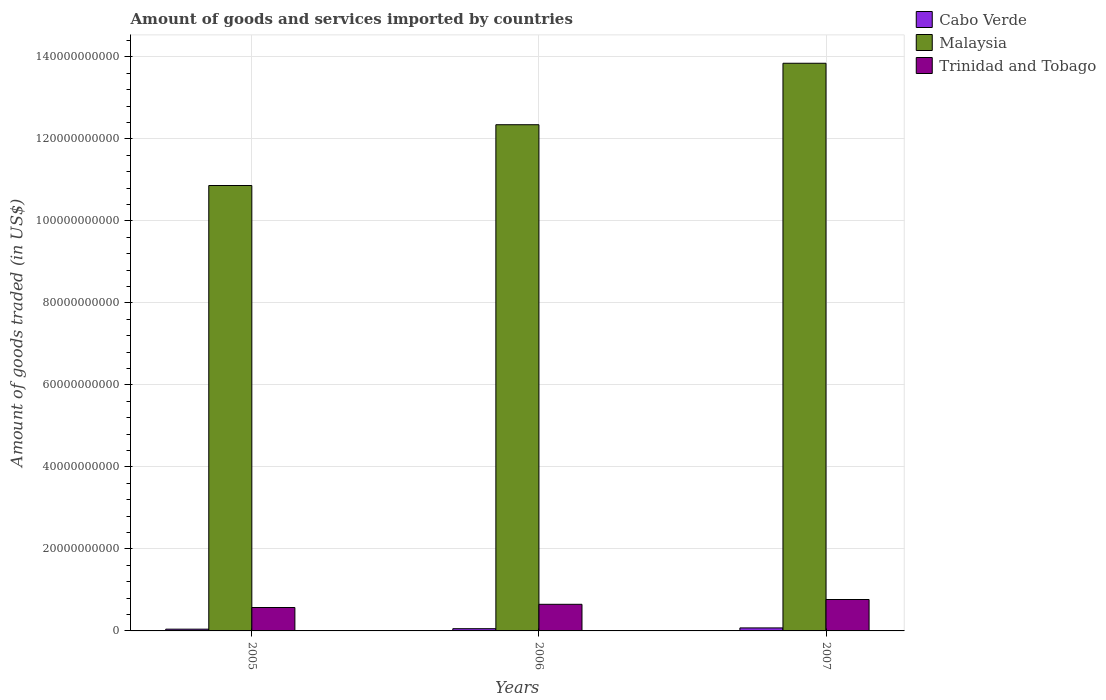How many different coloured bars are there?
Provide a short and direct response. 3. How many groups of bars are there?
Provide a short and direct response. 3. How many bars are there on the 3rd tick from the right?
Offer a very short reply. 3. In how many cases, is the number of bars for a given year not equal to the number of legend labels?
Provide a succinct answer. 0. What is the total amount of goods and services imported in Malaysia in 2005?
Your answer should be very brief. 1.09e+11. Across all years, what is the maximum total amount of goods and services imported in Trinidad and Tobago?
Give a very brief answer. 7.66e+09. Across all years, what is the minimum total amount of goods and services imported in Malaysia?
Your answer should be very brief. 1.09e+11. In which year was the total amount of goods and services imported in Trinidad and Tobago maximum?
Your answer should be compact. 2007. In which year was the total amount of goods and services imported in Cabo Verde minimum?
Your answer should be compact. 2005. What is the total total amount of goods and services imported in Malaysia in the graph?
Offer a terse response. 3.70e+11. What is the difference between the total amount of goods and services imported in Trinidad and Tobago in 2005 and that in 2007?
Provide a short and direct response. -1.95e+09. What is the difference between the total amount of goods and services imported in Malaysia in 2007 and the total amount of goods and services imported in Trinidad and Tobago in 2005?
Give a very brief answer. 1.33e+11. What is the average total amount of goods and services imported in Trinidad and Tobago per year?
Make the answer very short. 6.62e+09. In the year 2005, what is the difference between the total amount of goods and services imported in Trinidad and Tobago and total amount of goods and services imported in Cabo Verde?
Offer a very short reply. 5.28e+09. What is the ratio of the total amount of goods and services imported in Trinidad and Tobago in 2005 to that in 2006?
Provide a succinct answer. 0.88. What is the difference between the highest and the second highest total amount of goods and services imported in Cabo Verde?
Keep it short and to the point. 1.87e+08. What is the difference between the highest and the lowest total amount of goods and services imported in Malaysia?
Your response must be concise. 2.98e+1. What does the 2nd bar from the left in 2006 represents?
Offer a terse response. Malaysia. What does the 3rd bar from the right in 2006 represents?
Your answer should be very brief. Cabo Verde. Are all the bars in the graph horizontal?
Offer a very short reply. No. How many years are there in the graph?
Keep it short and to the point. 3. What is the difference between two consecutive major ticks on the Y-axis?
Your response must be concise. 2.00e+1. Does the graph contain any zero values?
Provide a succinct answer. No. What is the title of the graph?
Keep it short and to the point. Amount of goods and services imported by countries. Does "Middle East & North Africa (developing only)" appear as one of the legend labels in the graph?
Your answer should be compact. No. What is the label or title of the X-axis?
Your answer should be very brief. Years. What is the label or title of the Y-axis?
Make the answer very short. Amount of goods traded (in US$). What is the Amount of goods traded (in US$) in Cabo Verde in 2005?
Provide a succinct answer. 4.27e+08. What is the Amount of goods traded (in US$) in Malaysia in 2005?
Your response must be concise. 1.09e+11. What is the Amount of goods traded (in US$) in Trinidad and Tobago in 2005?
Offer a very short reply. 5.71e+09. What is the Amount of goods traded (in US$) in Cabo Verde in 2006?
Your answer should be compact. 5.45e+08. What is the Amount of goods traded (in US$) in Malaysia in 2006?
Offer a terse response. 1.23e+11. What is the Amount of goods traded (in US$) of Trinidad and Tobago in 2006?
Make the answer very short. 6.49e+09. What is the Amount of goods traded (in US$) in Cabo Verde in 2007?
Make the answer very short. 7.32e+08. What is the Amount of goods traded (in US$) in Malaysia in 2007?
Your response must be concise. 1.38e+11. What is the Amount of goods traded (in US$) of Trinidad and Tobago in 2007?
Give a very brief answer. 7.66e+09. Across all years, what is the maximum Amount of goods traded (in US$) in Cabo Verde?
Offer a terse response. 7.32e+08. Across all years, what is the maximum Amount of goods traded (in US$) in Malaysia?
Make the answer very short. 1.38e+11. Across all years, what is the maximum Amount of goods traded (in US$) in Trinidad and Tobago?
Provide a short and direct response. 7.66e+09. Across all years, what is the minimum Amount of goods traded (in US$) of Cabo Verde?
Provide a short and direct response. 4.27e+08. Across all years, what is the minimum Amount of goods traded (in US$) in Malaysia?
Ensure brevity in your answer.  1.09e+11. Across all years, what is the minimum Amount of goods traded (in US$) of Trinidad and Tobago?
Provide a short and direct response. 5.71e+09. What is the total Amount of goods traded (in US$) in Cabo Verde in the graph?
Offer a terse response. 1.70e+09. What is the total Amount of goods traded (in US$) of Malaysia in the graph?
Offer a terse response. 3.70e+11. What is the total Amount of goods traded (in US$) in Trinidad and Tobago in the graph?
Offer a very short reply. 1.99e+1. What is the difference between the Amount of goods traded (in US$) of Cabo Verde in 2005 and that in 2006?
Your response must be concise. -1.18e+08. What is the difference between the Amount of goods traded (in US$) of Malaysia in 2005 and that in 2006?
Give a very brief answer. -1.48e+1. What is the difference between the Amount of goods traded (in US$) in Trinidad and Tobago in 2005 and that in 2006?
Your answer should be compact. -7.81e+08. What is the difference between the Amount of goods traded (in US$) in Cabo Verde in 2005 and that in 2007?
Provide a succinct answer. -3.05e+08. What is the difference between the Amount of goods traded (in US$) in Malaysia in 2005 and that in 2007?
Give a very brief answer. -2.98e+1. What is the difference between the Amount of goods traded (in US$) in Trinidad and Tobago in 2005 and that in 2007?
Provide a short and direct response. -1.95e+09. What is the difference between the Amount of goods traded (in US$) in Cabo Verde in 2006 and that in 2007?
Give a very brief answer. -1.87e+08. What is the difference between the Amount of goods traded (in US$) of Malaysia in 2006 and that in 2007?
Make the answer very short. -1.50e+1. What is the difference between the Amount of goods traded (in US$) in Trinidad and Tobago in 2006 and that in 2007?
Offer a terse response. -1.17e+09. What is the difference between the Amount of goods traded (in US$) in Cabo Verde in 2005 and the Amount of goods traded (in US$) in Malaysia in 2006?
Provide a short and direct response. -1.23e+11. What is the difference between the Amount of goods traded (in US$) in Cabo Verde in 2005 and the Amount of goods traded (in US$) in Trinidad and Tobago in 2006?
Keep it short and to the point. -6.06e+09. What is the difference between the Amount of goods traded (in US$) of Malaysia in 2005 and the Amount of goods traded (in US$) of Trinidad and Tobago in 2006?
Give a very brief answer. 1.02e+11. What is the difference between the Amount of goods traded (in US$) of Cabo Verde in 2005 and the Amount of goods traded (in US$) of Malaysia in 2007?
Your answer should be compact. -1.38e+11. What is the difference between the Amount of goods traded (in US$) in Cabo Verde in 2005 and the Amount of goods traded (in US$) in Trinidad and Tobago in 2007?
Ensure brevity in your answer.  -7.24e+09. What is the difference between the Amount of goods traded (in US$) of Malaysia in 2005 and the Amount of goods traded (in US$) of Trinidad and Tobago in 2007?
Provide a succinct answer. 1.01e+11. What is the difference between the Amount of goods traded (in US$) in Cabo Verde in 2006 and the Amount of goods traded (in US$) in Malaysia in 2007?
Make the answer very short. -1.38e+11. What is the difference between the Amount of goods traded (in US$) of Cabo Verde in 2006 and the Amount of goods traded (in US$) of Trinidad and Tobago in 2007?
Make the answer very short. -7.12e+09. What is the difference between the Amount of goods traded (in US$) of Malaysia in 2006 and the Amount of goods traded (in US$) of Trinidad and Tobago in 2007?
Your answer should be compact. 1.16e+11. What is the average Amount of goods traded (in US$) in Cabo Verde per year?
Provide a succinct answer. 5.68e+08. What is the average Amount of goods traded (in US$) of Malaysia per year?
Your answer should be compact. 1.23e+11. What is the average Amount of goods traded (in US$) in Trinidad and Tobago per year?
Provide a short and direct response. 6.62e+09. In the year 2005, what is the difference between the Amount of goods traded (in US$) of Cabo Verde and Amount of goods traded (in US$) of Malaysia?
Your answer should be compact. -1.08e+11. In the year 2005, what is the difference between the Amount of goods traded (in US$) in Cabo Verde and Amount of goods traded (in US$) in Trinidad and Tobago?
Offer a terse response. -5.28e+09. In the year 2005, what is the difference between the Amount of goods traded (in US$) of Malaysia and Amount of goods traded (in US$) of Trinidad and Tobago?
Offer a terse response. 1.03e+11. In the year 2006, what is the difference between the Amount of goods traded (in US$) of Cabo Verde and Amount of goods traded (in US$) of Malaysia?
Give a very brief answer. -1.23e+11. In the year 2006, what is the difference between the Amount of goods traded (in US$) of Cabo Verde and Amount of goods traded (in US$) of Trinidad and Tobago?
Offer a terse response. -5.95e+09. In the year 2006, what is the difference between the Amount of goods traded (in US$) in Malaysia and Amount of goods traded (in US$) in Trinidad and Tobago?
Give a very brief answer. 1.17e+11. In the year 2007, what is the difference between the Amount of goods traded (in US$) of Cabo Verde and Amount of goods traded (in US$) of Malaysia?
Provide a short and direct response. -1.38e+11. In the year 2007, what is the difference between the Amount of goods traded (in US$) of Cabo Verde and Amount of goods traded (in US$) of Trinidad and Tobago?
Keep it short and to the point. -6.93e+09. In the year 2007, what is the difference between the Amount of goods traded (in US$) in Malaysia and Amount of goods traded (in US$) in Trinidad and Tobago?
Provide a short and direct response. 1.31e+11. What is the ratio of the Amount of goods traded (in US$) of Cabo Verde in 2005 to that in 2006?
Ensure brevity in your answer.  0.78. What is the ratio of the Amount of goods traded (in US$) of Malaysia in 2005 to that in 2006?
Give a very brief answer. 0.88. What is the ratio of the Amount of goods traded (in US$) of Trinidad and Tobago in 2005 to that in 2006?
Your answer should be very brief. 0.88. What is the ratio of the Amount of goods traded (in US$) of Cabo Verde in 2005 to that in 2007?
Offer a very short reply. 0.58. What is the ratio of the Amount of goods traded (in US$) of Malaysia in 2005 to that in 2007?
Your response must be concise. 0.78. What is the ratio of the Amount of goods traded (in US$) in Trinidad and Tobago in 2005 to that in 2007?
Make the answer very short. 0.75. What is the ratio of the Amount of goods traded (in US$) in Cabo Verde in 2006 to that in 2007?
Offer a very short reply. 0.74. What is the ratio of the Amount of goods traded (in US$) of Malaysia in 2006 to that in 2007?
Give a very brief answer. 0.89. What is the ratio of the Amount of goods traded (in US$) in Trinidad and Tobago in 2006 to that in 2007?
Keep it short and to the point. 0.85. What is the difference between the highest and the second highest Amount of goods traded (in US$) of Cabo Verde?
Ensure brevity in your answer.  1.87e+08. What is the difference between the highest and the second highest Amount of goods traded (in US$) in Malaysia?
Provide a short and direct response. 1.50e+1. What is the difference between the highest and the second highest Amount of goods traded (in US$) of Trinidad and Tobago?
Offer a very short reply. 1.17e+09. What is the difference between the highest and the lowest Amount of goods traded (in US$) in Cabo Verde?
Offer a very short reply. 3.05e+08. What is the difference between the highest and the lowest Amount of goods traded (in US$) of Malaysia?
Ensure brevity in your answer.  2.98e+1. What is the difference between the highest and the lowest Amount of goods traded (in US$) in Trinidad and Tobago?
Your answer should be compact. 1.95e+09. 